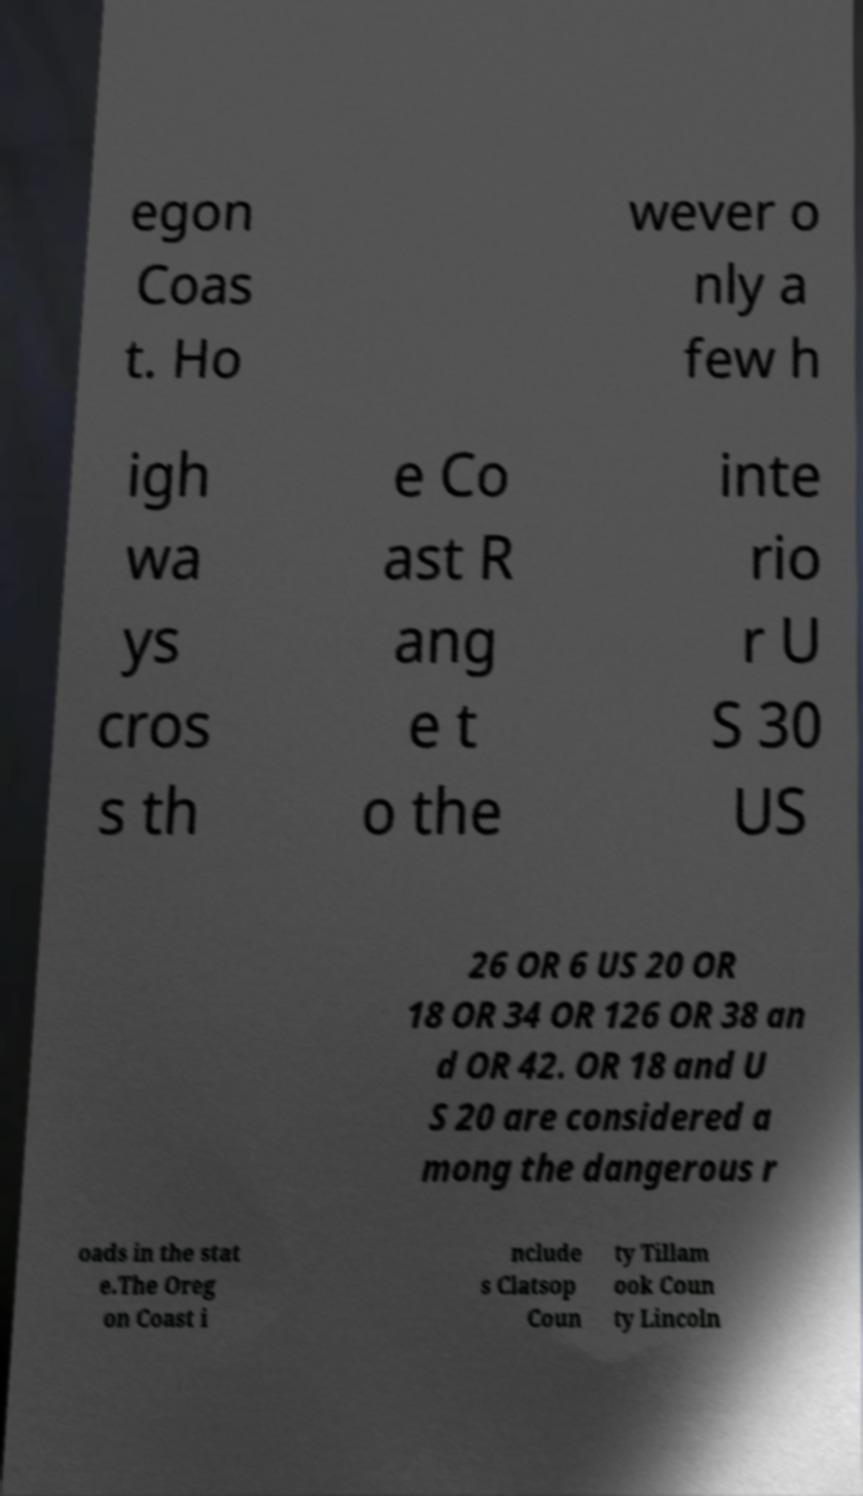There's text embedded in this image that I need extracted. Can you transcribe it verbatim? egon Coas t. Ho wever o nly a few h igh wa ys cros s th e Co ast R ang e t o the inte rio r U S 30 US 26 OR 6 US 20 OR 18 OR 34 OR 126 OR 38 an d OR 42. OR 18 and U S 20 are considered a mong the dangerous r oads in the stat e.The Oreg on Coast i nclude s Clatsop Coun ty Tillam ook Coun ty Lincoln 